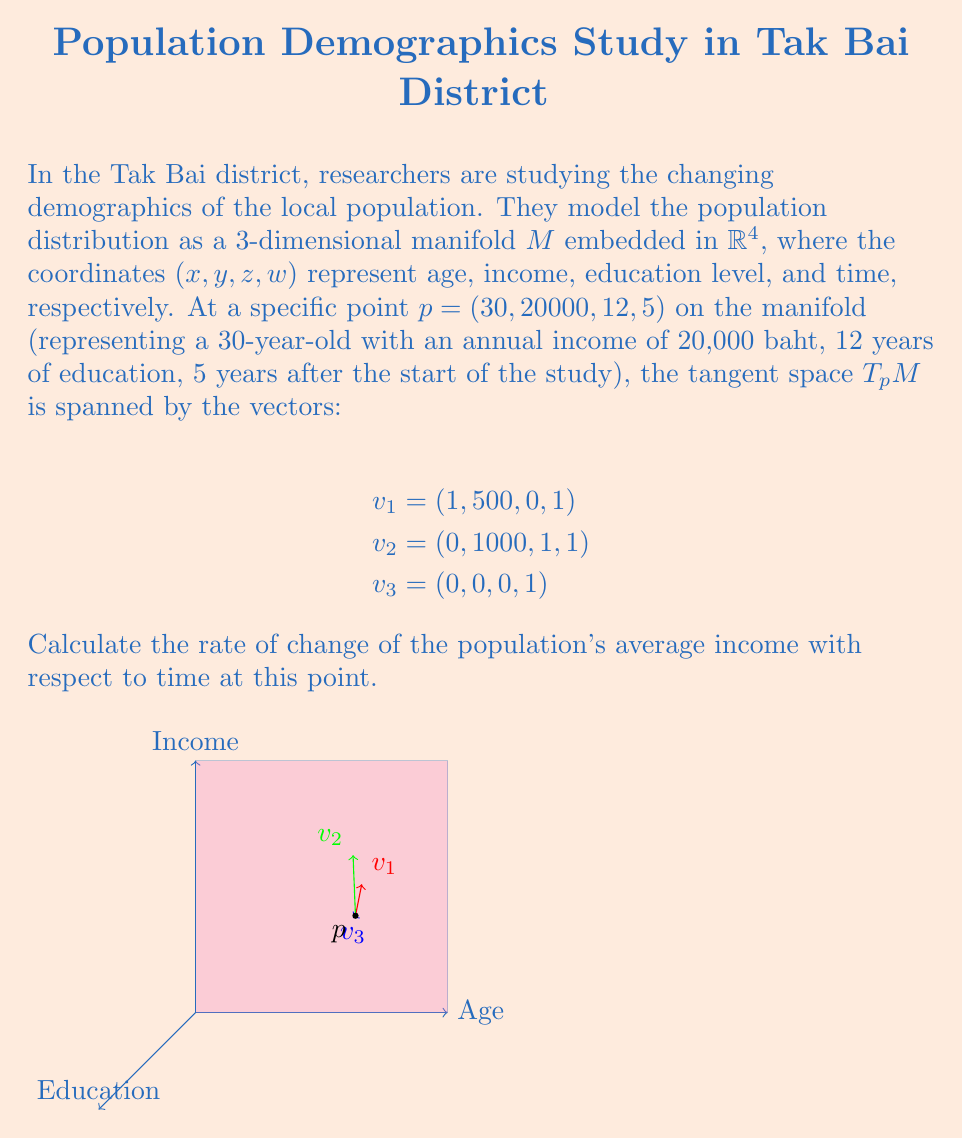Give your solution to this math problem. To solve this problem, we'll follow these steps:

1) The rate of change of income with respect to time is represented by the partial derivative $\frac{\partial w}{\partial t}$, where $w$ is income and $t$ is time.

2) In the tangent space, the vector that represents pure time change is $v_3 = (0, 0, 0, 1)$.

3) We need to find a linear combination of $v_1$, $v_2$, and $v_3$ that gives us a vector in the form $(0, \frac{\partial w}{\partial t}, 0, 1)$. This vector will represent how all variables change with respect to time.

4) Let's say this linear combination is $av_1 + bv_2 + cv_3$:

   $a(1, 500, 0, 1) + b(0, 1000, 1, 1) + c(0, 0, 0, 1) = (0, \frac{\partial w}{\partial t}, 0, 1)$

5) Comparing coefficients:

   $a = 0$ (for the first coordinate)
   $500a + 1000b = \frac{\partial w}{\partial t}$ (for the second coordinate)
   $b = 0$ (for the third coordinate)
   $a + b + c = 1$ (for the fourth coordinate)

6) From these equations, we can deduce:
   $a = 0$
   $b = 0$
   $c = 1$

7) Substituting these back into the equation for $\frac{\partial w}{\partial t}$:

   $\frac{\partial w}{\partial t} = 500(0) + 1000(0) = 0$

Therefore, at this specific point, the rate of change of the average income with respect to time is 0 baht per year.
Answer: $\frac{\partial w}{\partial t} = 0$ baht/year 